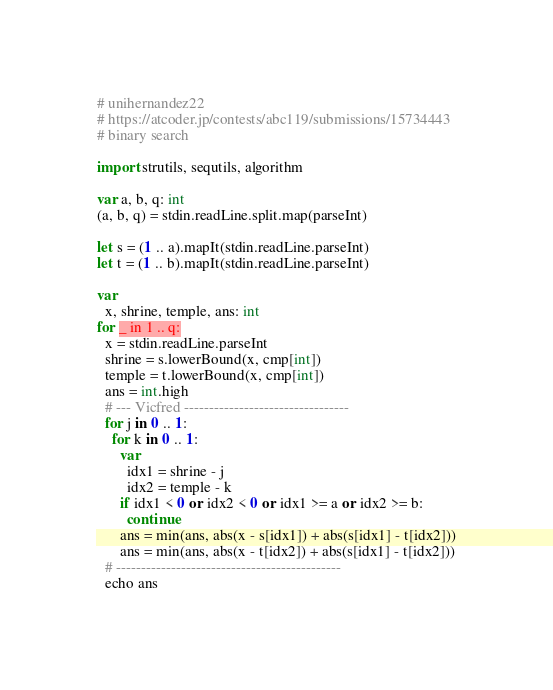Convert code to text. <code><loc_0><loc_0><loc_500><loc_500><_Nim_># unihernandez22
# https://atcoder.jp/contests/abc119/submissions/15734443
# binary search

import strutils, sequtils, algorithm

var a, b, q: int
(a, b, q) = stdin.readLine.split.map(parseInt)

let s = (1 .. a).mapIt(stdin.readLine.parseInt)
let t = (1 .. b).mapIt(stdin.readLine.parseInt)

var
  x, shrine, temple, ans: int
for _ in 1 .. q:
  x = stdin.readLine.parseInt
  shrine = s.lowerBound(x, cmp[int])
  temple = t.lowerBound(x, cmp[int])
  ans = int.high
  # --- Vicfred ---------------------------------
  for j in 0 .. 1:
    for k in 0 .. 1:
      var
        idx1 = shrine - j
        idx2 = temple - k
      if idx1 < 0 or idx2 < 0 or idx1 >= a or idx2 >= b:
        continue
      ans = min(ans, abs(x - s[idx1]) + abs(s[idx1] - t[idx2]))
      ans = min(ans, abs(x - t[idx2]) + abs(s[idx1] - t[idx2]))
  # ---------------------------------------------
  echo ans

</code> 